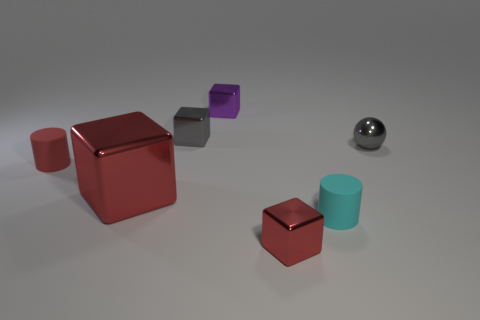Subtract all purple cubes. How many cubes are left? 3 Subtract all large metal blocks. How many blocks are left? 3 Subtract all cyan cubes. Subtract all gray balls. How many cubes are left? 4 Add 1 purple objects. How many objects exist? 8 Subtract all cylinders. How many objects are left? 5 Subtract all small gray blocks. Subtract all small metallic objects. How many objects are left? 2 Add 2 rubber cylinders. How many rubber cylinders are left? 4 Add 2 cyan matte cylinders. How many cyan matte cylinders exist? 3 Subtract 0 blue cubes. How many objects are left? 7 